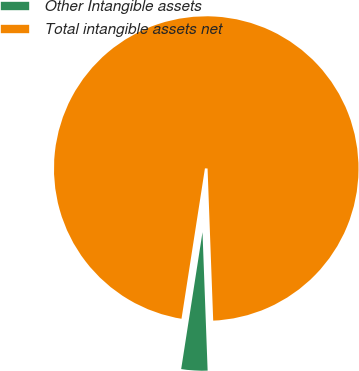Convert chart. <chart><loc_0><loc_0><loc_500><loc_500><pie_chart><fcel>Other Intangible assets<fcel>Total intangible assets net<nl><fcel>3.05%<fcel>96.95%<nl></chart> 